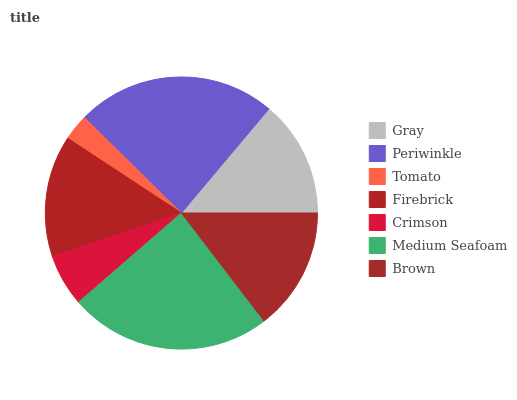Is Tomato the minimum?
Answer yes or no. Yes. Is Medium Seafoam the maximum?
Answer yes or no. Yes. Is Periwinkle the minimum?
Answer yes or no. No. Is Periwinkle the maximum?
Answer yes or no. No. Is Periwinkle greater than Gray?
Answer yes or no. Yes. Is Gray less than Periwinkle?
Answer yes or no. Yes. Is Gray greater than Periwinkle?
Answer yes or no. No. Is Periwinkle less than Gray?
Answer yes or no. No. Is Firebrick the high median?
Answer yes or no. Yes. Is Firebrick the low median?
Answer yes or no. Yes. Is Medium Seafoam the high median?
Answer yes or no. No. Is Brown the low median?
Answer yes or no. No. 